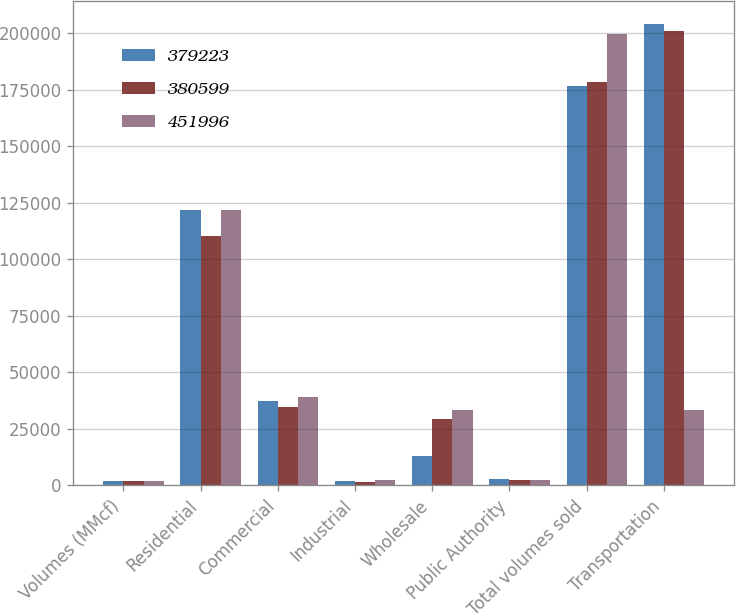Convert chart. <chart><loc_0><loc_0><loc_500><loc_500><stacked_bar_chart><ecel><fcel>Volumes (MMcf)<fcel>Residential<fcel>Commercial<fcel>Industrial<fcel>Wholesale<fcel>Public Authority<fcel>Total volumes sold<fcel>Transportation<nl><fcel>379223<fcel>2007<fcel>121587<fcel>37295<fcel>1758<fcel>13231<fcel>2679<fcel>176550<fcel>204049<nl><fcel>380599<fcel>2006<fcel>110123<fcel>34865<fcel>1624<fcel>29263<fcel>2520<fcel>178395<fcel>200828<nl><fcel>451996<fcel>2005<fcel>122010<fcel>39294<fcel>2432<fcel>33521<fcel>2559<fcel>199816<fcel>33521<nl></chart> 